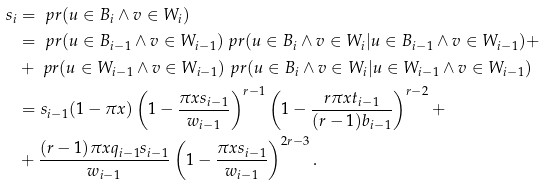<formula> <loc_0><loc_0><loc_500><loc_500>s _ { i } & = \ p r ( u \in B _ { i } \wedge v \in W _ { i } ) \\ & = \ p r ( u \in B _ { i - 1 } \wedge v \in W _ { i - 1 } ) \ p r ( u \in B _ { i } \wedge v \in W _ { i } | u \in B _ { i - 1 } \wedge v \in W _ { i - 1 } ) + \\ & + \ p r ( u \in W _ { i - 1 } \wedge v \in W _ { i - 1 } ) \ p r ( u \in B _ { i } \wedge v \in W _ { i } | u \in W _ { i - 1 } \wedge v \in W _ { i - 1 } ) \\ & = s _ { i - 1 } ( 1 - \pi x ) \left ( 1 - \frac { \pi x s _ { i - 1 } } { w _ { i - 1 } } \right ) ^ { r - 1 } \left ( 1 - \frac { r \pi x t _ { i - 1 } } { ( r - 1 ) b _ { i - 1 } } \right ) ^ { r - 2 } + \\ & + \frac { ( r - 1 ) \pi x q _ { i - 1 } s _ { i - 1 } } { w _ { i - 1 } } \left ( 1 - \frac { \pi x s _ { i - 1 } } { w _ { i - 1 } } \right ) ^ { 2 r - 3 } .</formula> 